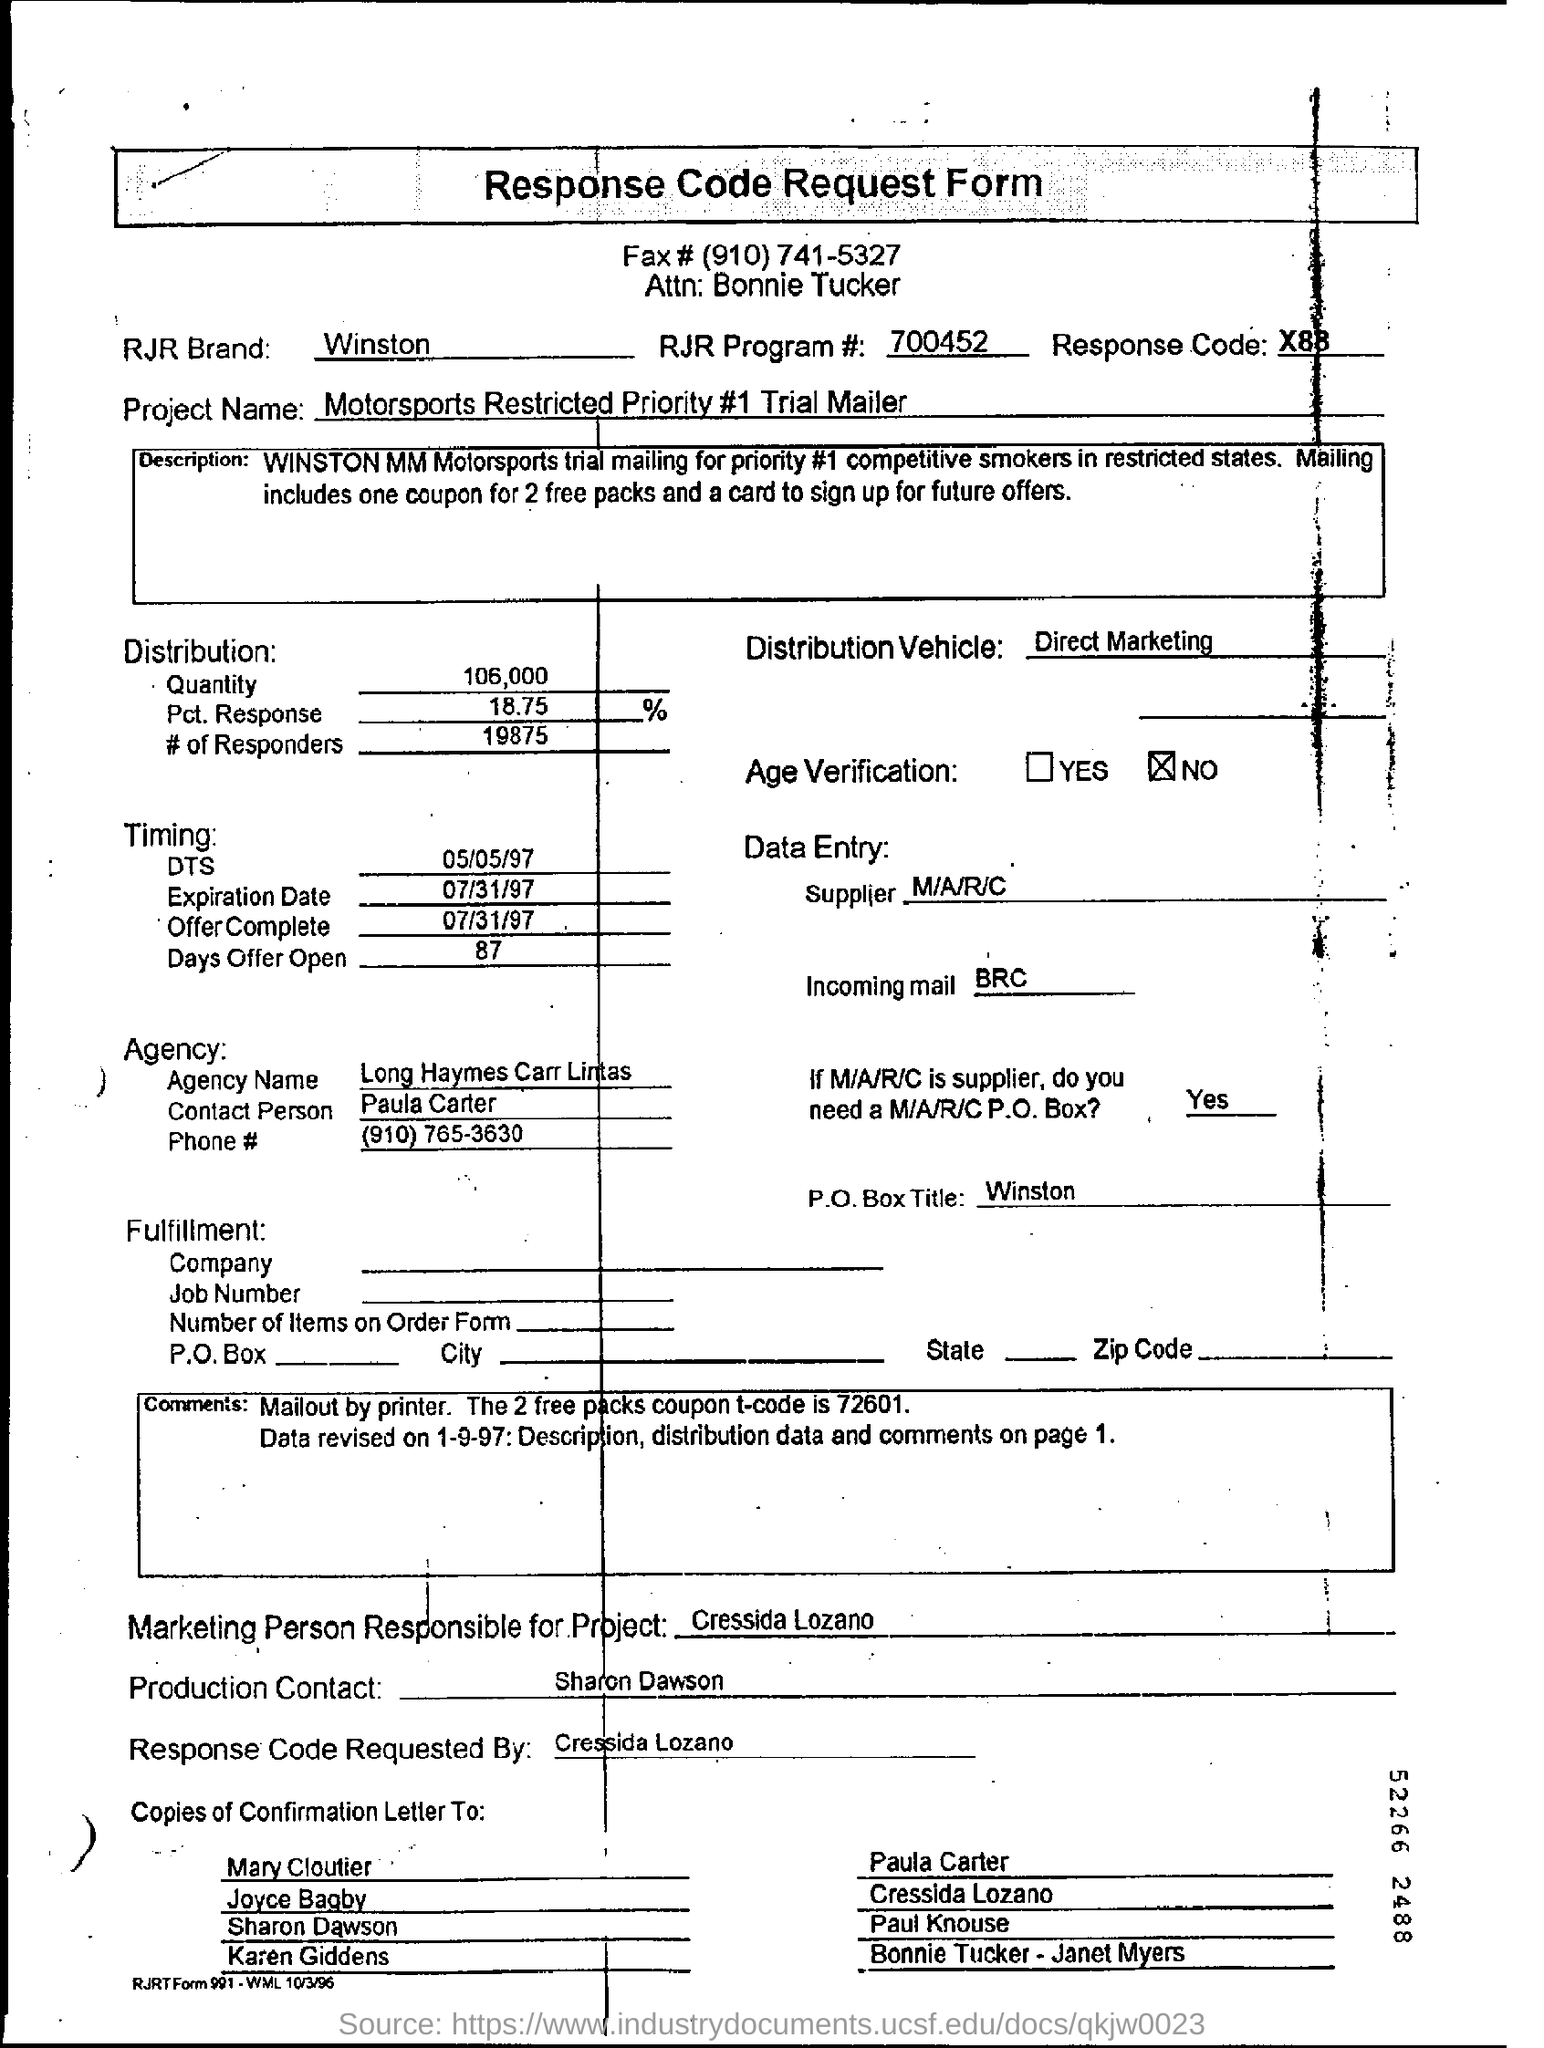What is the heading of the document?
Keep it short and to the point. Response Code Request Form. What is the RJR Brand?
Provide a succinct answer. Winston. 